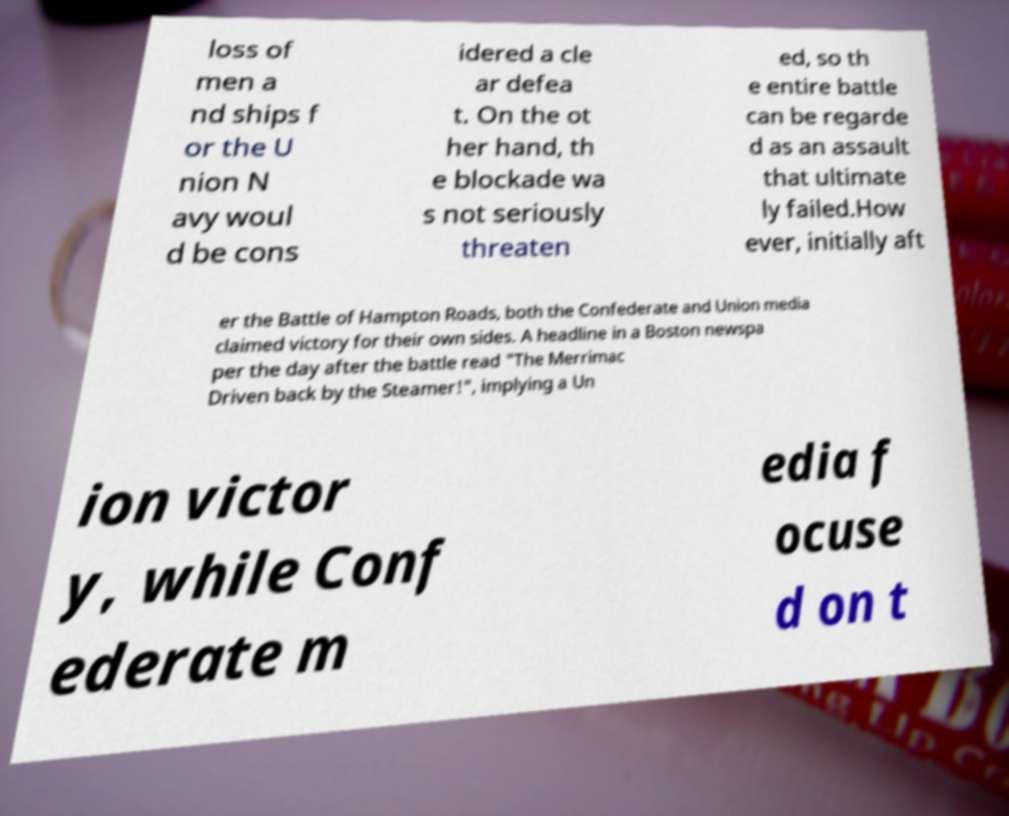Could you assist in decoding the text presented in this image and type it out clearly? loss of men a nd ships f or the U nion N avy woul d be cons idered a cle ar defea t. On the ot her hand, th e blockade wa s not seriously threaten ed, so th e entire battle can be regarde d as an assault that ultimate ly failed.How ever, initially aft er the Battle of Hampton Roads, both the Confederate and Union media claimed victory for their own sides. A headline in a Boston newspa per the day after the battle read "The Merrimac Driven back by the Steamer!", implying a Un ion victor y, while Conf ederate m edia f ocuse d on t 